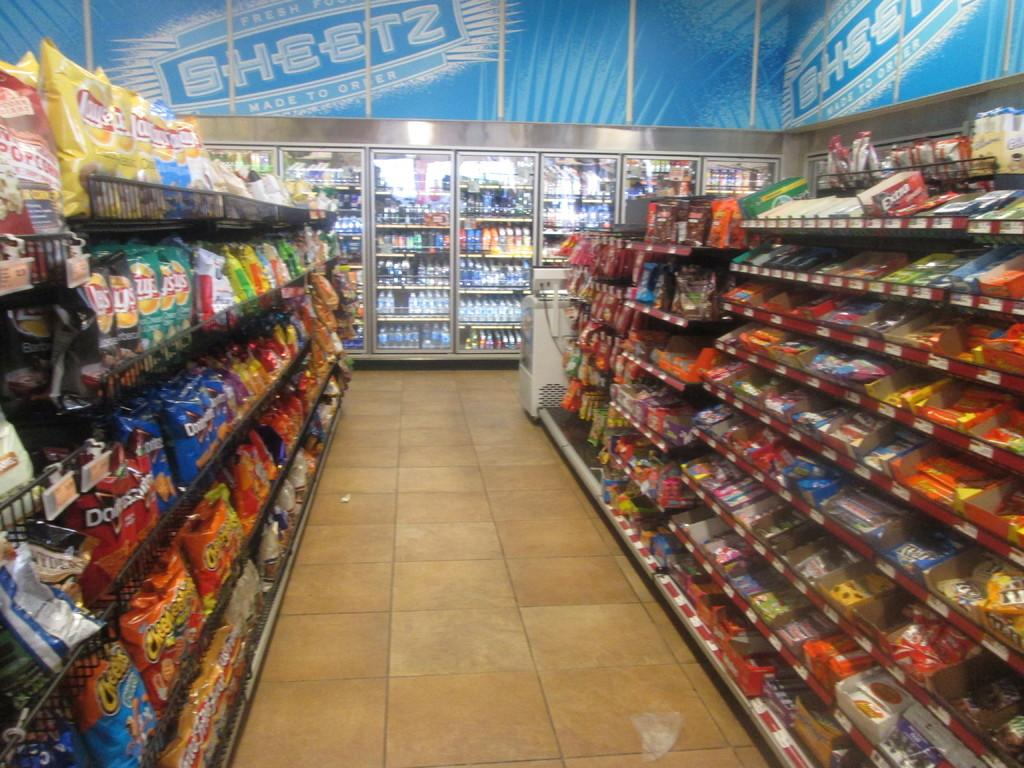<image>
Describe the image concisely. Empty store aisle with the worsd Sheetz on top of the freezers. 